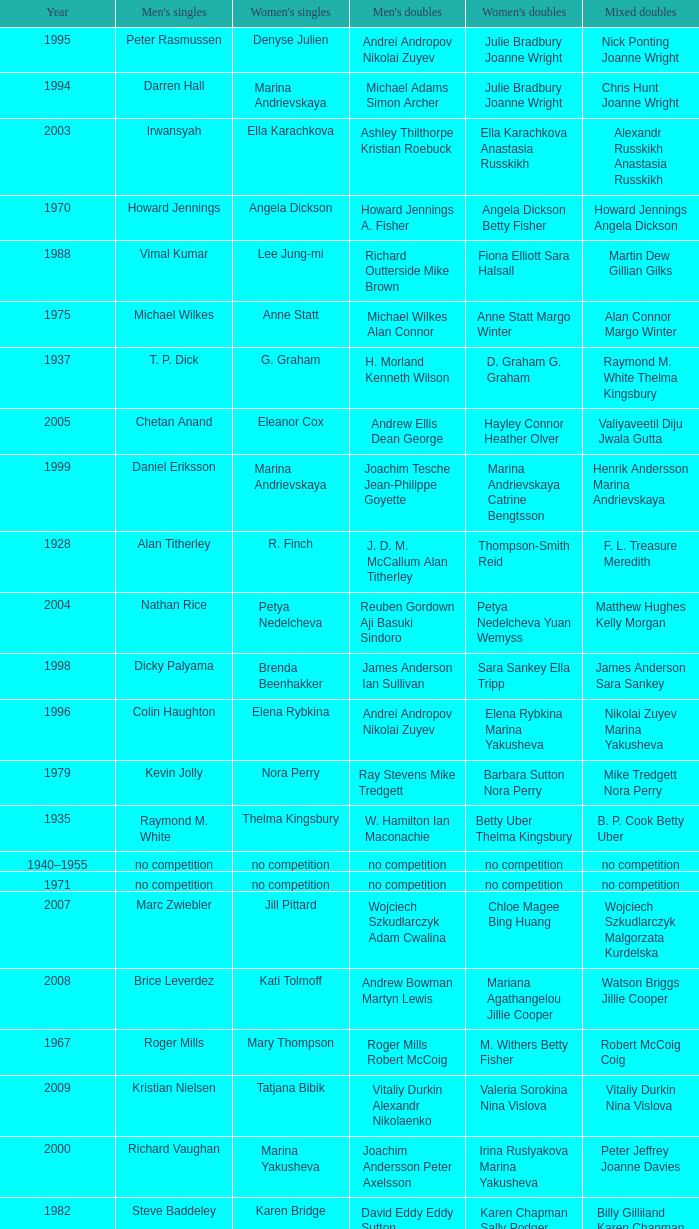Who won the Women's doubles in the year that Jesper Knudsen Nettie Nielsen won the Mixed doubles? Karen Beckman Sara Halsall. 